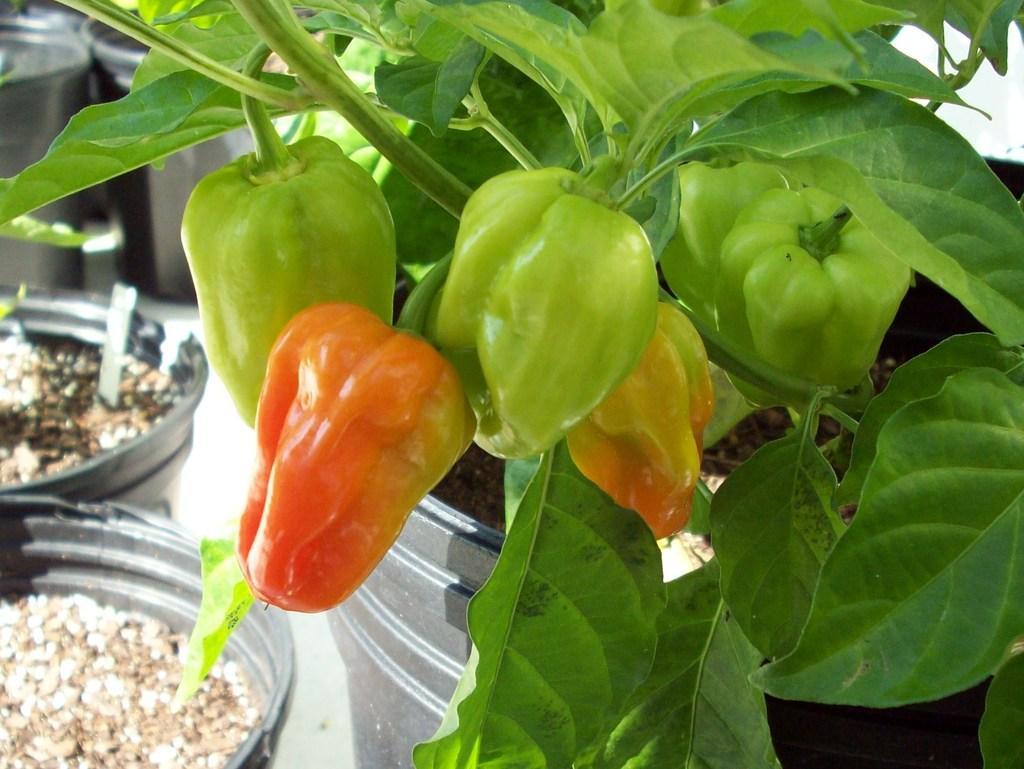Describe this image in one or two sentences. We can see plant, vegetables and potatoes on the surface. 